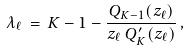<formula> <loc_0><loc_0><loc_500><loc_500>\lambda _ { \ell } \, = \, K - 1 - \frac { Q _ { K - 1 } ( z _ { \ell } ) } { z _ { \ell } \, Q ^ { \prime } _ { K } ( z _ { \ell } ) } \, ,</formula> 